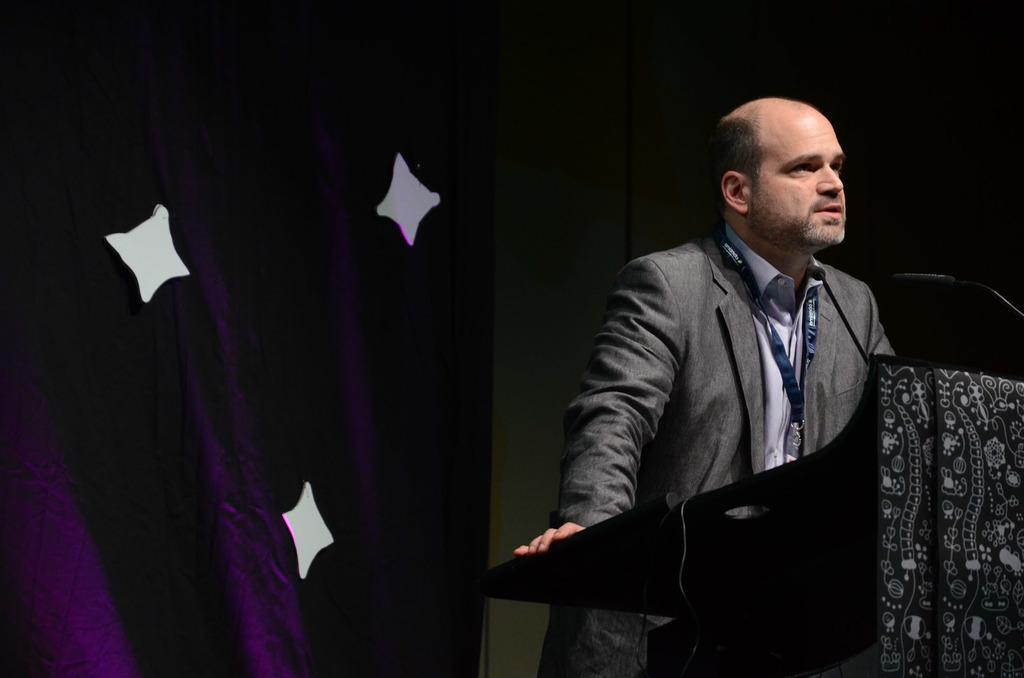What is the main subject of the image? There is a person in the image. What is the person wearing? The person is wearing a suit. What is the person doing in the image? The person is standing and speaking in front of a microphone. Where is the microphone located in the image? The microphone is in the right corner of the image. What color is the cloth in the background? There is a violet-colored cloth in the background. Are there any cobwebs visible in the image? There is no mention of cobwebs in the provided facts, and therefore, we cannot determine if any are present in the image. Is there a turkey in the image? There is no mention of a turkey in the provided facts, and therefore, we cannot determine if one is present in the image. 